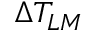<formula> <loc_0><loc_0><loc_500><loc_500>\Delta T _ { L M }</formula> 